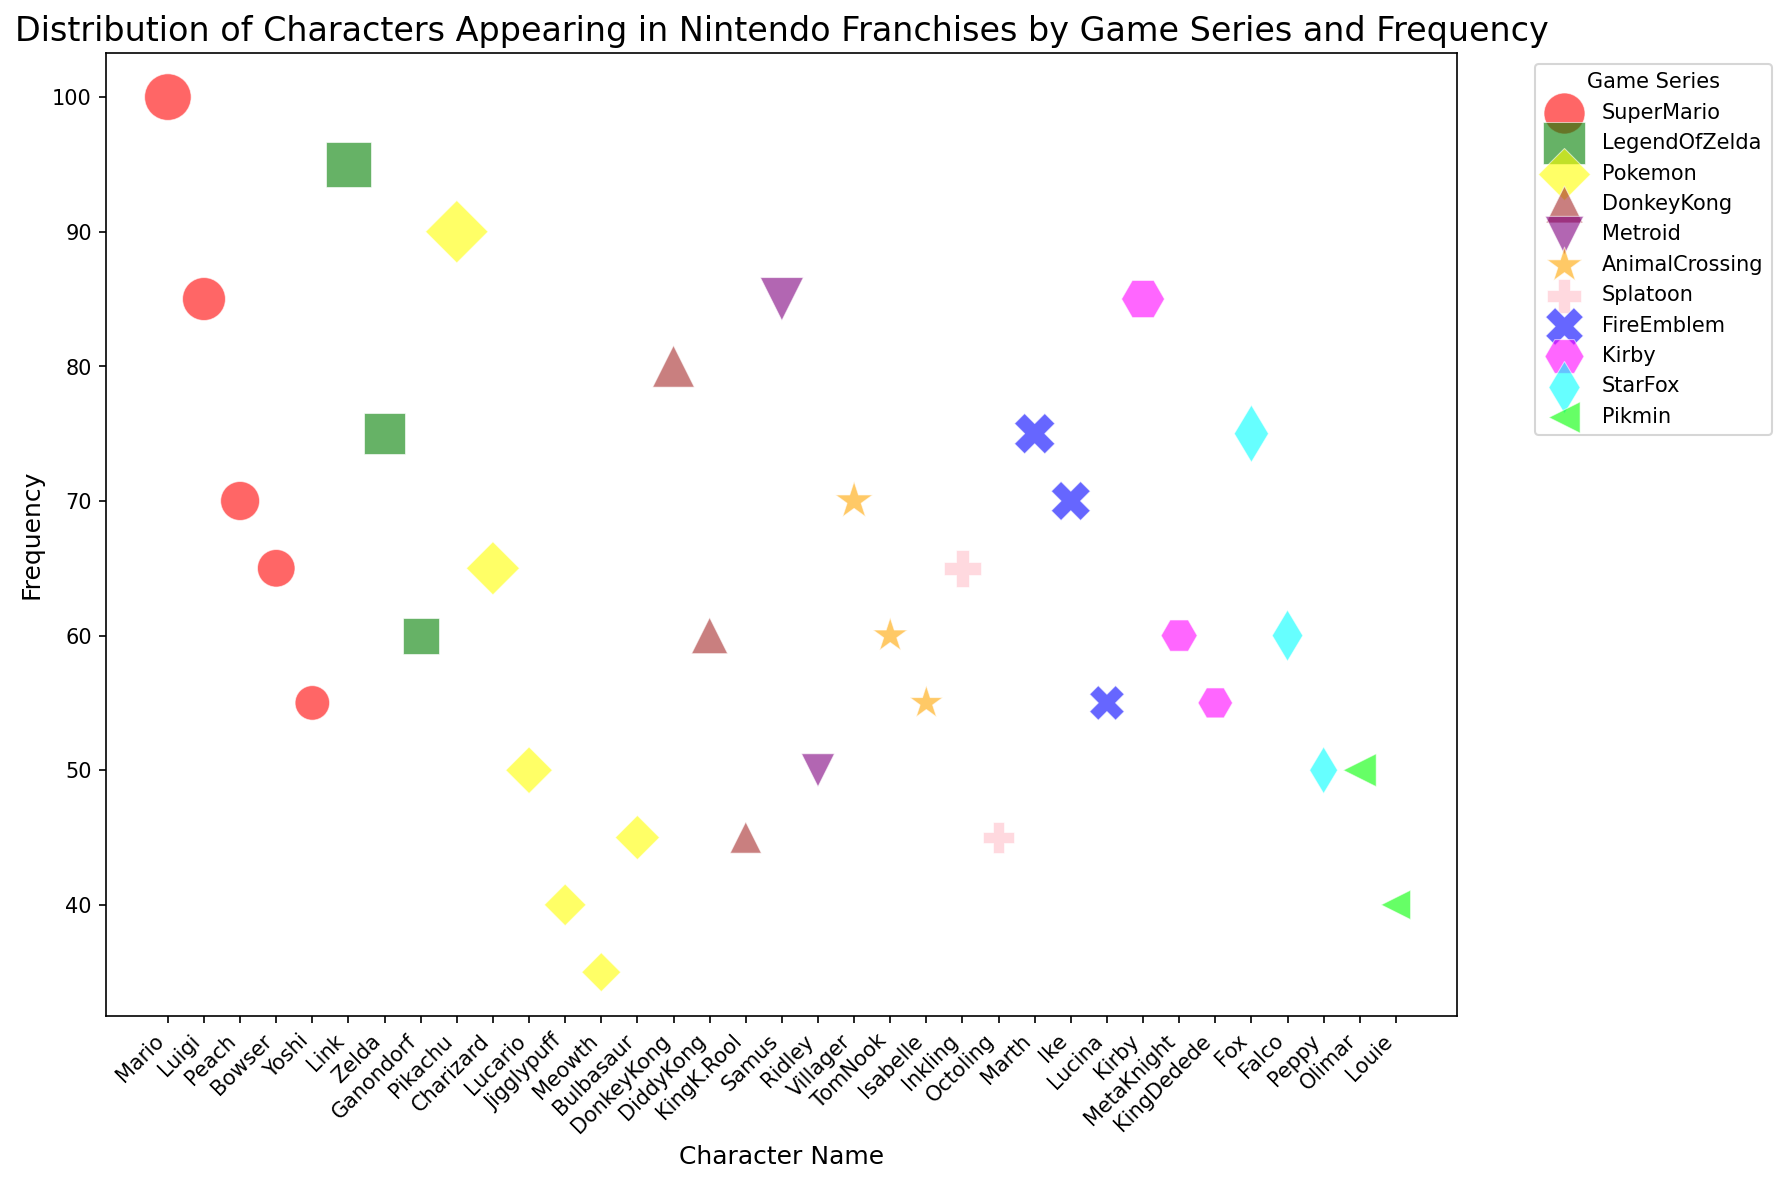What's the character with the highest frequency? First, identify the character with the largest bubble. The largest bubble belongs to Mario from the Super Mario series, indicated by its size and position on the upper end of the y-axis.
Answer: Mario Which game series has the most characters with a frequency above 60? Count the number of characters with frequencies above 60 for each game series. Super Mario has Mario (100), Luigi (85), Peach (70), and Bowser (65), totaling 4 characters.
Answer: Super Mario How does Pikachu's frequency compare to Link's? Look at the y-axis values for Pikachu and Link. Pikachu has a frequency of 90, and Link has a frequency of 95, so Link has a slightly higher frequency.
Answer: Link has a higher frequency than Pikachu Which game series has the most diverse range of character frequencies? Observe each series and determine which one has the widest range between the highest and lowest frequencies. Super Mario, with frequent characters ranging from 100 (Mario) to 55 (Yoshi), shows a high range.
Answer: Super Mario What is the average frequency of the characters in the Kirby series? Sum the frequencies of Kirby (85), Meta Knight (60), and King Dedede (55). The total is 200. Divide by the number of characters: 200 / 3 ≈ 66.67.
Answer: 66.67 What character in the Fire Emblem series has a frequency closest to 60? Identify frequencies of Fire Emblem characters: Marth (75), Ike (70), and Lucina (55). Lucina, with a frequency of 55, is closest to 60.
Answer: Lucina Compare the highest frequency characters in Pokémon and Metroid. Which one has a higher frequency? Identify the highest frequency characters in each series: Pikachu (90) for Pokémon and Samus (85) for Metroid. Pikachu has a higher frequency.
Answer: Pikachu What is the combined frequency of the three most frequent characters in the Legend of Zelda series? Add the frequencies of the three most frequent characters: Link (95), Zelda (75), and Ganondorf (60). 95 + 75 + 60 = 230.
Answer: 230 Which series has more characters with frequencies less than 50, Pokémon or Fire Emblem? Count characters with frequencies below 50 in each series. Pokémon: Jigglypuff (40) and Meowth (35), totaling 2. Fire Emblem: None. Pokémon has more.
Answer: Pokémon Which two game series have the most characters with close or equal frequencies? Compare characters' frequencies across series to find close values. Animal Crossing and Kirby each have characters with similar frequencies around 55 and 60: Animal Crossing (Isabelle 55, Tom Nook 60) and Kirby (Meta Knight 60, King Dedede 55).
Answer: Animal Crossing and Kirby 